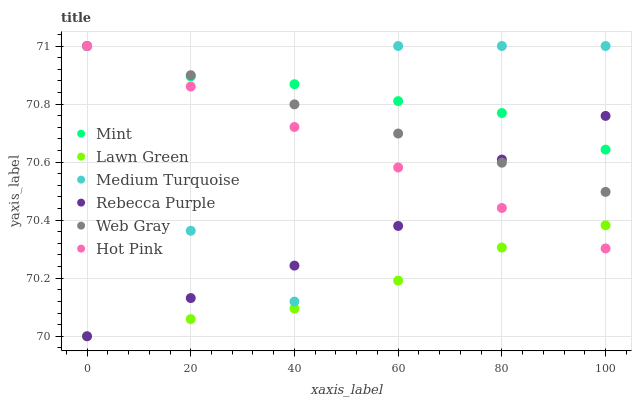Does Lawn Green have the minimum area under the curve?
Answer yes or no. Yes. Does Mint have the maximum area under the curve?
Answer yes or no. Yes. Does Web Gray have the minimum area under the curve?
Answer yes or no. No. Does Web Gray have the maximum area under the curve?
Answer yes or no. No. Is Hot Pink the smoothest?
Answer yes or no. Yes. Is Medium Turquoise the roughest?
Answer yes or no. Yes. Is Web Gray the smoothest?
Answer yes or no. No. Is Web Gray the roughest?
Answer yes or no. No. Does Lawn Green have the lowest value?
Answer yes or no. Yes. Does Web Gray have the lowest value?
Answer yes or no. No. Does Mint have the highest value?
Answer yes or no. Yes. Does Rebecca Purple have the highest value?
Answer yes or no. No. Is Lawn Green less than Mint?
Answer yes or no. Yes. Is Mint greater than Lawn Green?
Answer yes or no. Yes. Does Medium Turquoise intersect Hot Pink?
Answer yes or no. Yes. Is Medium Turquoise less than Hot Pink?
Answer yes or no. No. Is Medium Turquoise greater than Hot Pink?
Answer yes or no. No. Does Lawn Green intersect Mint?
Answer yes or no. No. 